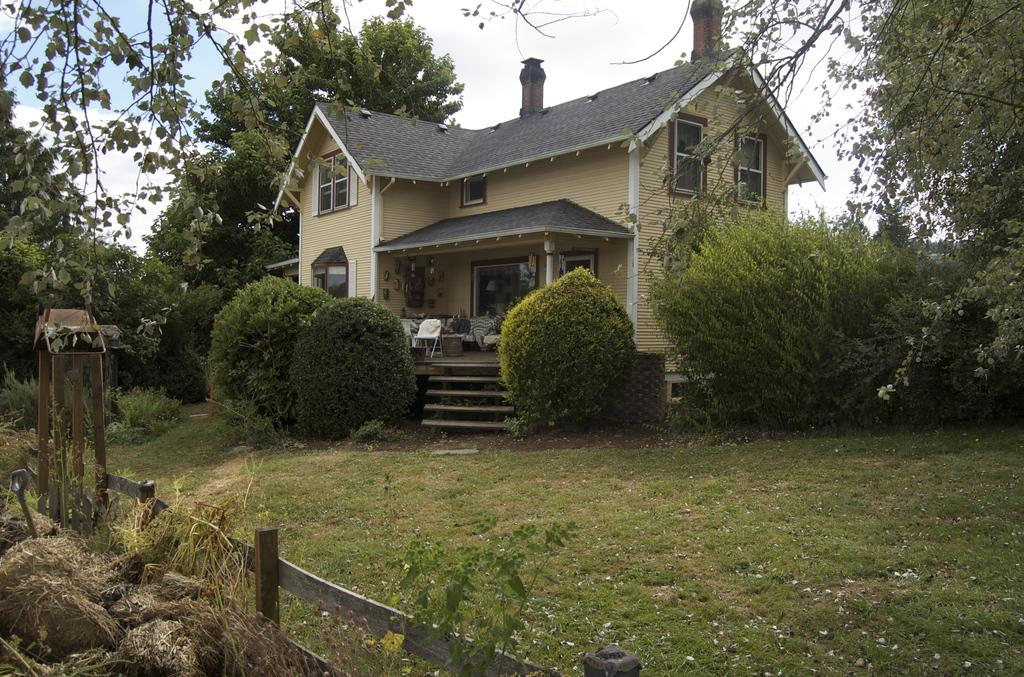What type of structure is visible in the image? There is a house in the image. What furniture can be seen inside the house? There are chairs and a table visible inside the house. What is present on both sides of the image? There are trees on both the right and left sides of the image. How would you describe the sky in the image? The sky is blue and cloudy in the image. What type of vest is hanging on the wall in the image? There is no vest present in the image. What reward is being given to the person in the image? There is no person or reward present in the image. 